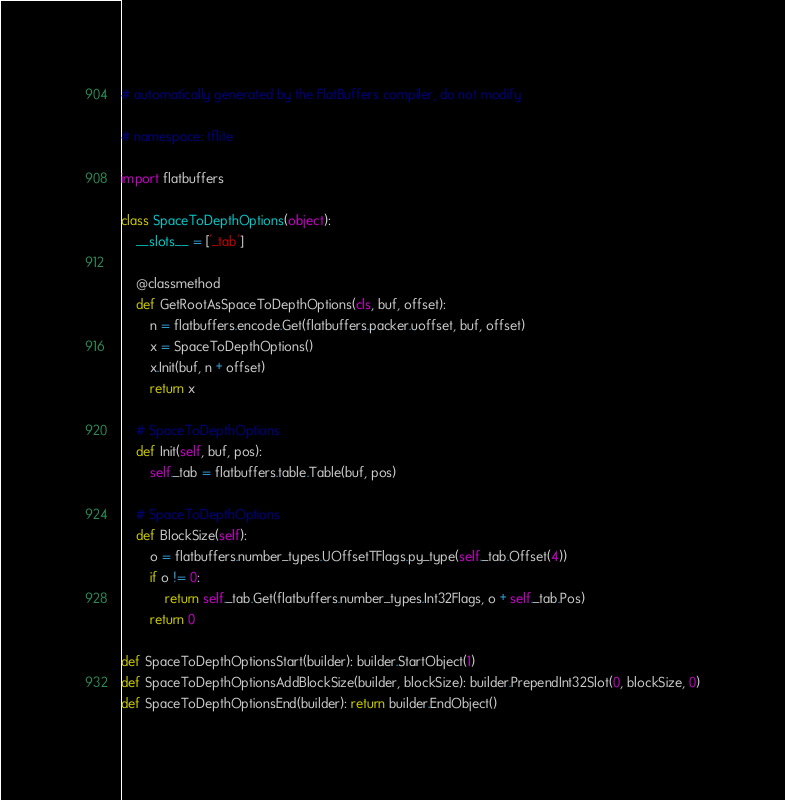<code> <loc_0><loc_0><loc_500><loc_500><_Python_># automatically generated by the FlatBuffers compiler, do not modify

# namespace: tflite

import flatbuffers

class SpaceToDepthOptions(object):
    __slots__ = ['_tab']

    @classmethod
    def GetRootAsSpaceToDepthOptions(cls, buf, offset):
        n = flatbuffers.encode.Get(flatbuffers.packer.uoffset, buf, offset)
        x = SpaceToDepthOptions()
        x.Init(buf, n + offset)
        return x

    # SpaceToDepthOptions
    def Init(self, buf, pos):
        self._tab = flatbuffers.table.Table(buf, pos)

    # SpaceToDepthOptions
    def BlockSize(self):
        o = flatbuffers.number_types.UOffsetTFlags.py_type(self._tab.Offset(4))
        if o != 0:
            return self._tab.Get(flatbuffers.number_types.Int32Flags, o + self._tab.Pos)
        return 0

def SpaceToDepthOptionsStart(builder): builder.StartObject(1)
def SpaceToDepthOptionsAddBlockSize(builder, blockSize): builder.PrependInt32Slot(0, blockSize, 0)
def SpaceToDepthOptionsEnd(builder): return builder.EndObject()
</code> 